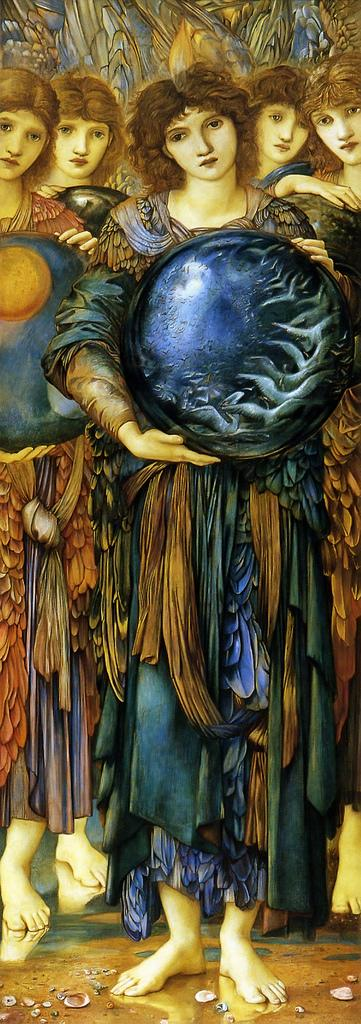What is the main subject of the image? There is a painting in the image. What is happening in the painting? The painting depicts people standing. What are the people in the painting doing with their hands? The people in the painting are holding objects in their hands. What type of wind can be seen blowing through the painting in the image? There is no wind present in the painting; it is a static image. 